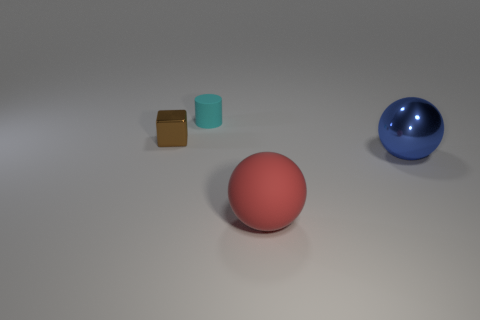Add 4 small purple spheres. How many objects exist? 8 Subtract all blocks. How many objects are left? 3 Subtract all big cyan metal objects. Subtract all small brown blocks. How many objects are left? 3 Add 1 brown cubes. How many brown cubes are left? 2 Add 4 metal cubes. How many metal cubes exist? 5 Subtract 0 purple cylinders. How many objects are left? 4 